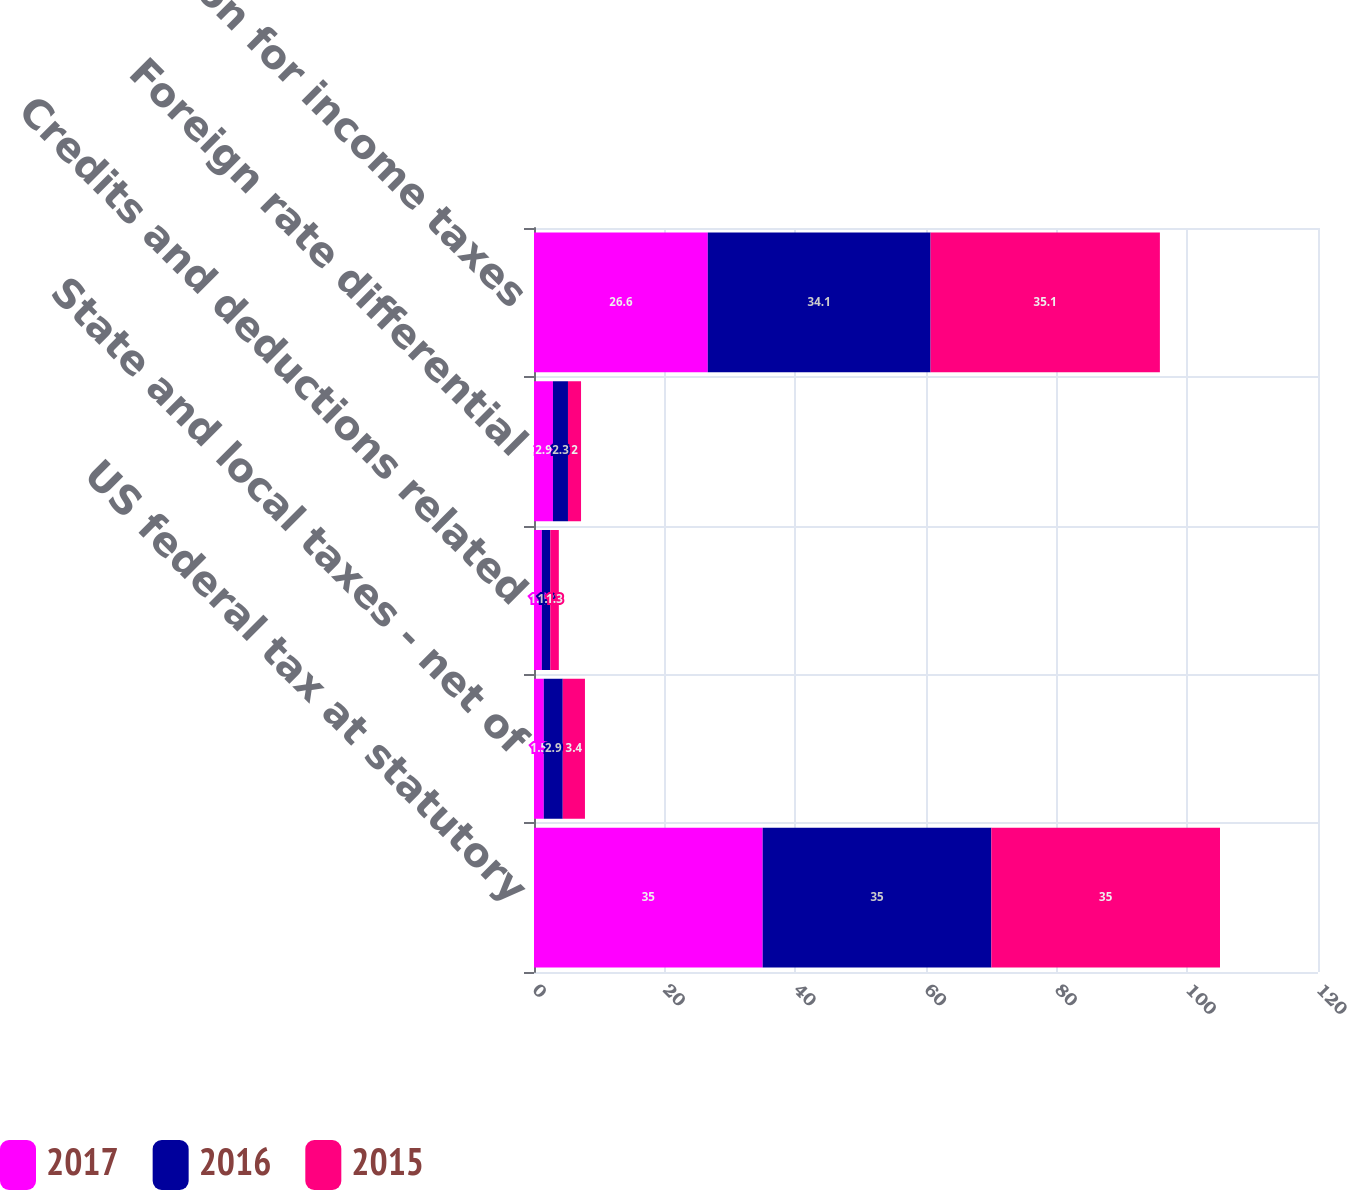Convert chart to OTSL. <chart><loc_0><loc_0><loc_500><loc_500><stacked_bar_chart><ecel><fcel>US federal tax at statutory<fcel>State and local taxes - net of<fcel>Credits and deductions related<fcel>Foreign rate differential<fcel>Provision for income taxes<nl><fcel>2017<fcel>35<fcel>1.5<fcel>1.2<fcel>2.9<fcel>26.6<nl><fcel>2016<fcel>35<fcel>2.9<fcel>1.3<fcel>2.3<fcel>34.1<nl><fcel>2015<fcel>35<fcel>3.4<fcel>1.3<fcel>2<fcel>35.1<nl></chart> 